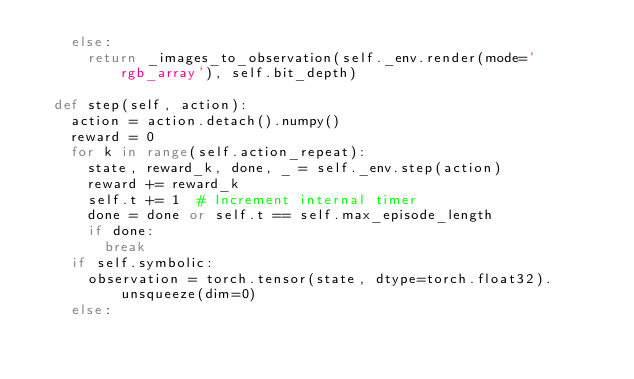<code> <loc_0><loc_0><loc_500><loc_500><_Python_>    else:
      return _images_to_observation(self._env.render(mode='rgb_array'), self.bit_depth)
  
  def step(self, action):
    action = action.detach().numpy()
    reward = 0
    for k in range(self.action_repeat):
      state, reward_k, done, _ = self._env.step(action)
      reward += reward_k
      self.t += 1  # Increment internal timer
      done = done or self.t == self.max_episode_length
      if done:
        break
    if self.symbolic:
      observation = torch.tensor(state, dtype=torch.float32).unsqueeze(dim=0)
    else:</code> 